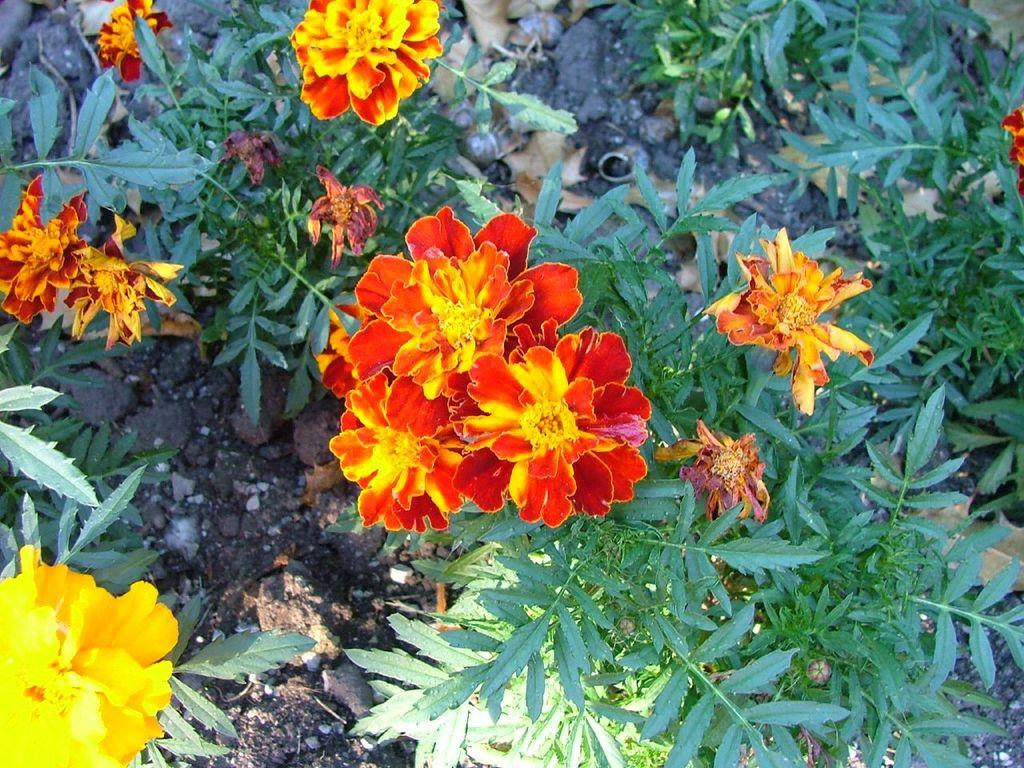What colors are the flowers on the plant in the image? There are yellow and red flowers on the plant in the image. What type of car is parked next to the plant in the image? There is no car present in the image; it only features a plant with yellow and red flowers. 